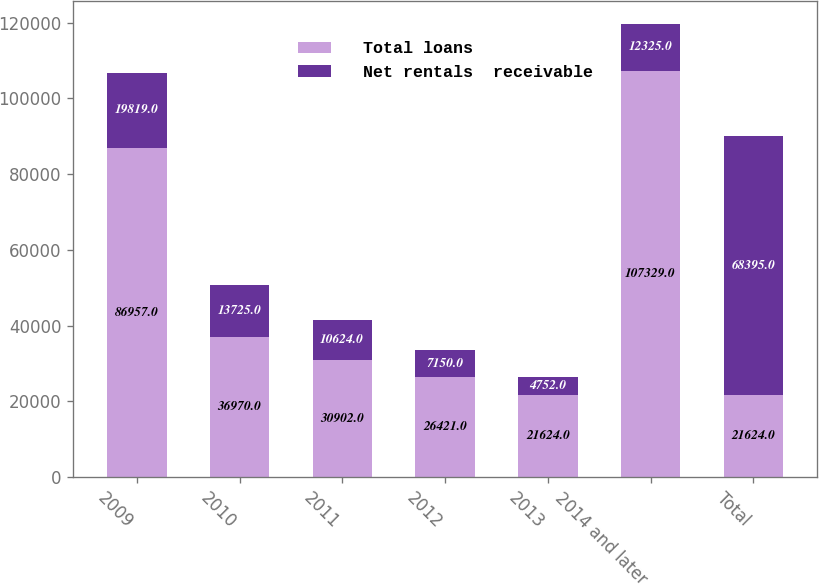Convert chart to OTSL. <chart><loc_0><loc_0><loc_500><loc_500><stacked_bar_chart><ecel><fcel>2009<fcel>2010<fcel>2011<fcel>2012<fcel>2013<fcel>2014 and later<fcel>Total<nl><fcel>Total loans<fcel>86957<fcel>36970<fcel>30902<fcel>26421<fcel>21624<fcel>107329<fcel>21624<nl><fcel>Net rentals  receivable<fcel>19819<fcel>13725<fcel>10624<fcel>7150<fcel>4752<fcel>12325<fcel>68395<nl></chart> 